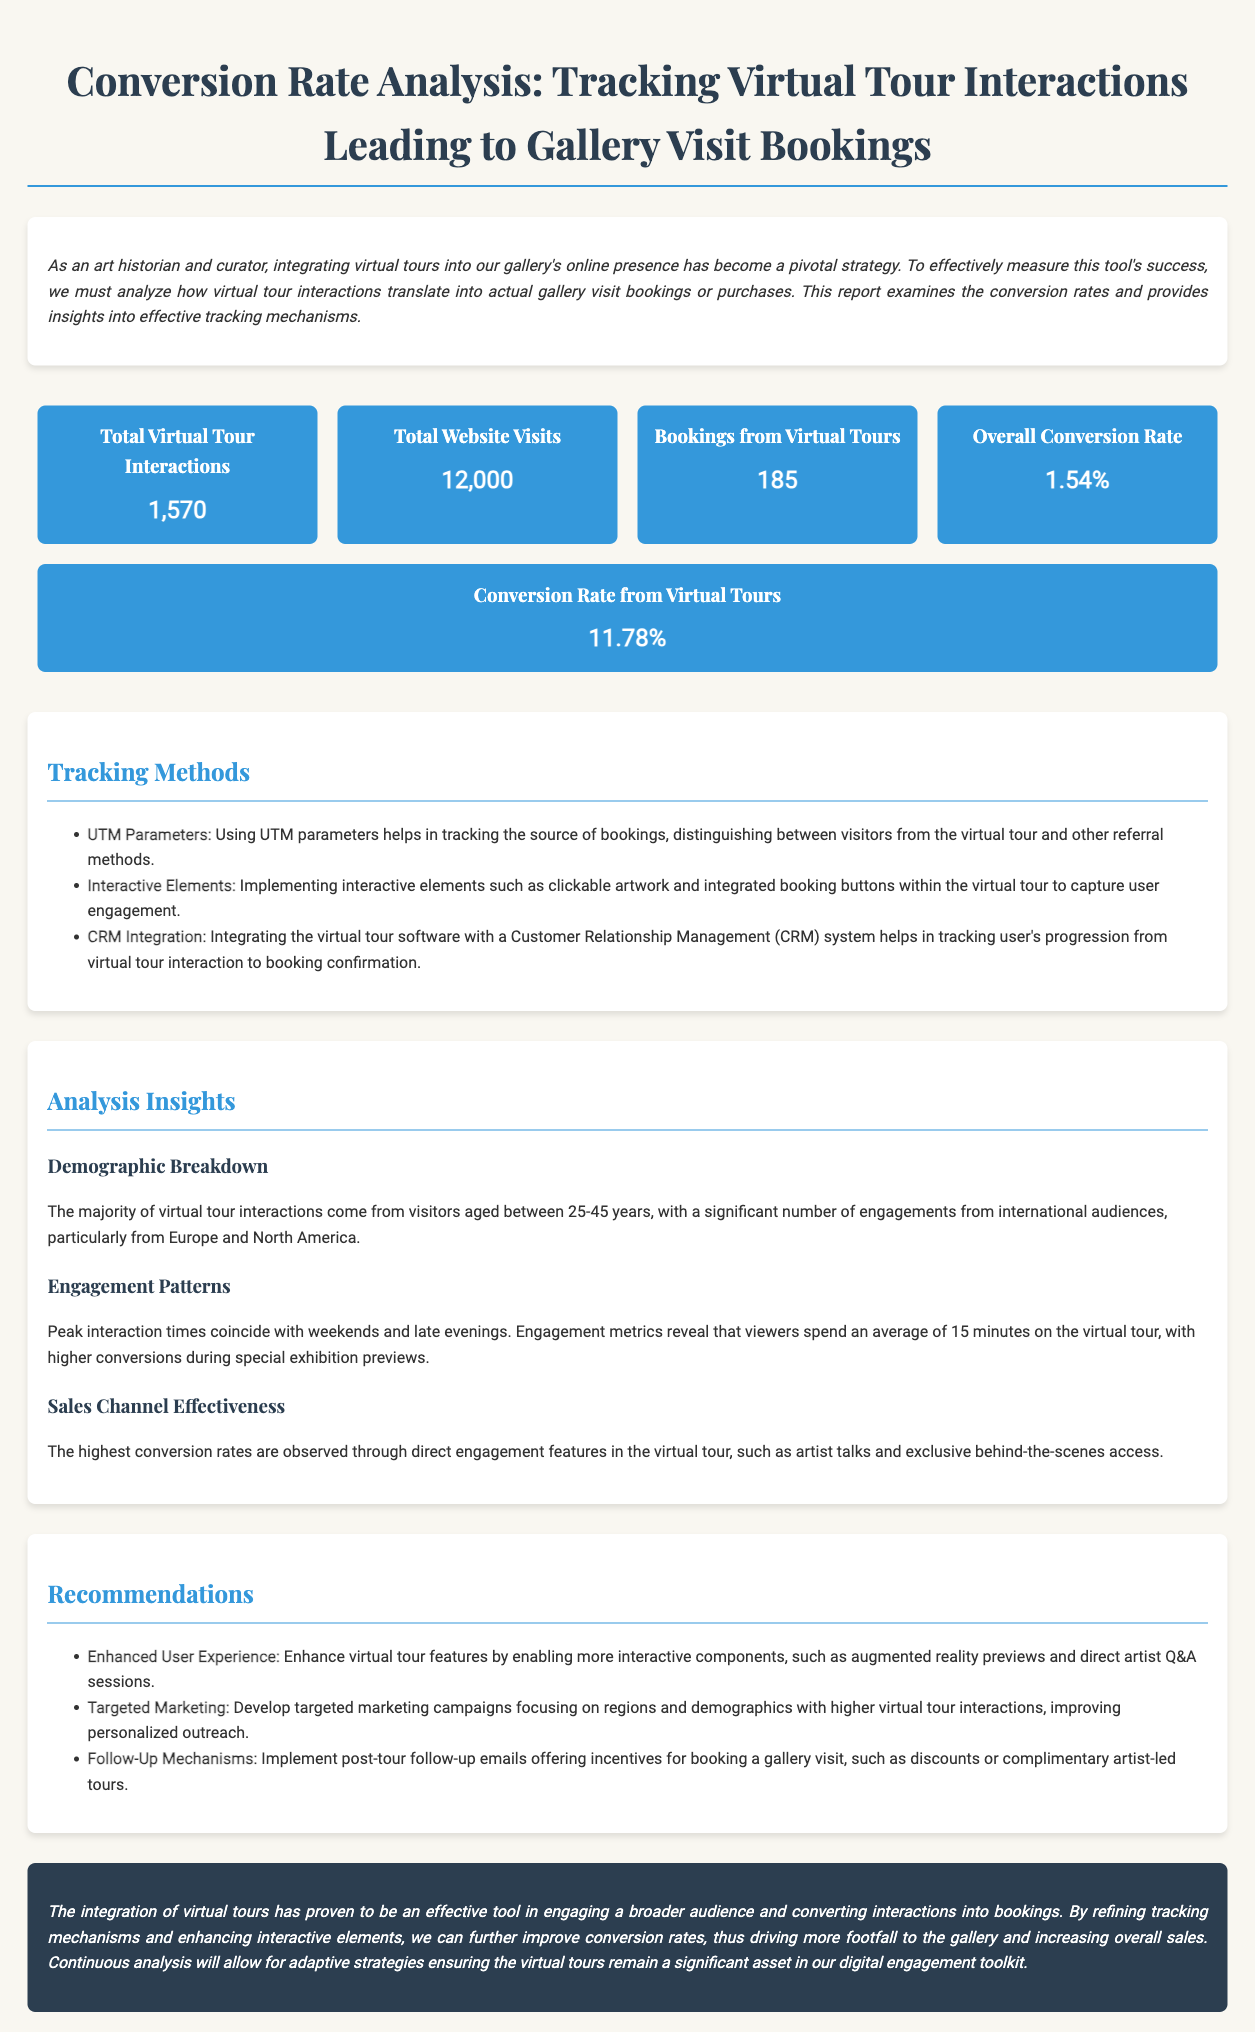what is the total number of virtual tour interactions? The total number of virtual tour interactions is listed as 1,570 in the document.
Answer: 1,570 what is the overall conversion rate? The overall conversion rate is mentioned as 1.54% in the metrics section.
Answer: 1.54% how many bookings resulted from virtual tours? The document states there were 185 bookings that came from virtual tours.
Answer: 185 which demographics show the highest engagement? The analysis mentions that most interactions come from visitors aged between 25-45 years.
Answer: 25-45 years what is the average time spent on the virtual tour? The document indicates that viewers spend an average of 15 minutes on the virtual tour.
Answer: 15 minutes what feature has the highest conversion rates? The analysis highlights that direct engagement features in the virtual tour have the highest conversion rates.
Answer: direct engagement features what is the primary goal of the tracking methods section? The section aims to describe mechanisms to track the effectiveness of virtual tours in converting visitors to bookings.
Answer: track effectiveness what recommendation suggests improving user experience? It suggests enhancing virtual tour features with more interactive components, such as augmented reality previews.
Answer: enhance interactive components how many total website visits are reported? The total number of website visits reported is 12,000 in the metrics.
Answer: 12,000 